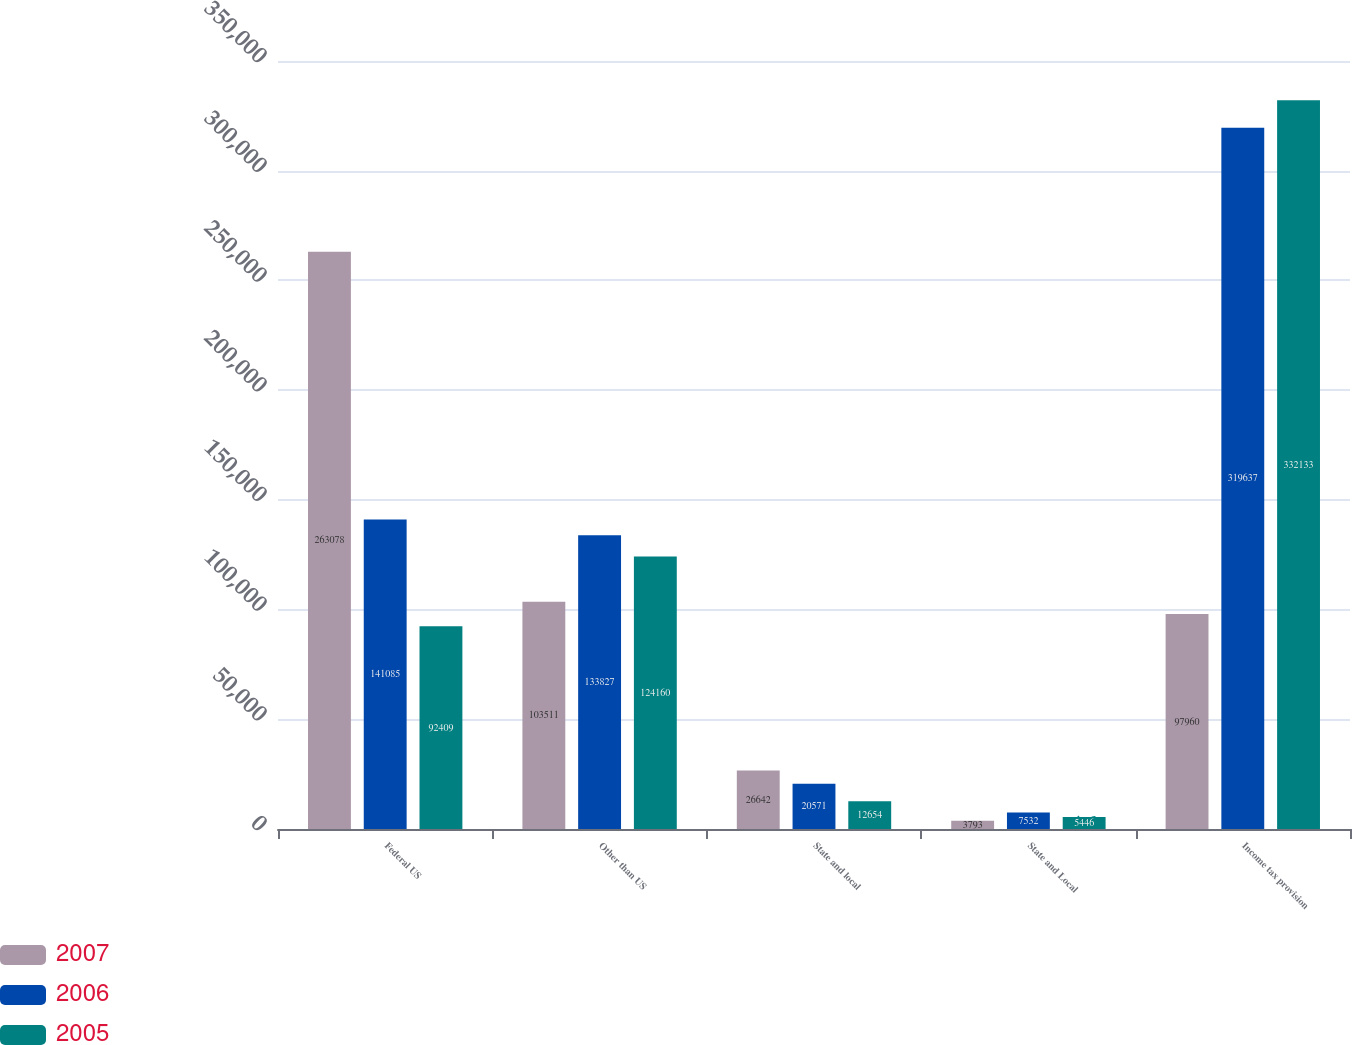Convert chart to OTSL. <chart><loc_0><loc_0><loc_500><loc_500><stacked_bar_chart><ecel><fcel>Federal US<fcel>Other than US<fcel>State and local<fcel>State and Local<fcel>Income tax provision<nl><fcel>2007<fcel>263078<fcel>103511<fcel>26642<fcel>3793<fcel>97960<nl><fcel>2006<fcel>141085<fcel>133827<fcel>20571<fcel>7532<fcel>319637<nl><fcel>2005<fcel>92409<fcel>124160<fcel>12654<fcel>5446<fcel>332133<nl></chart> 